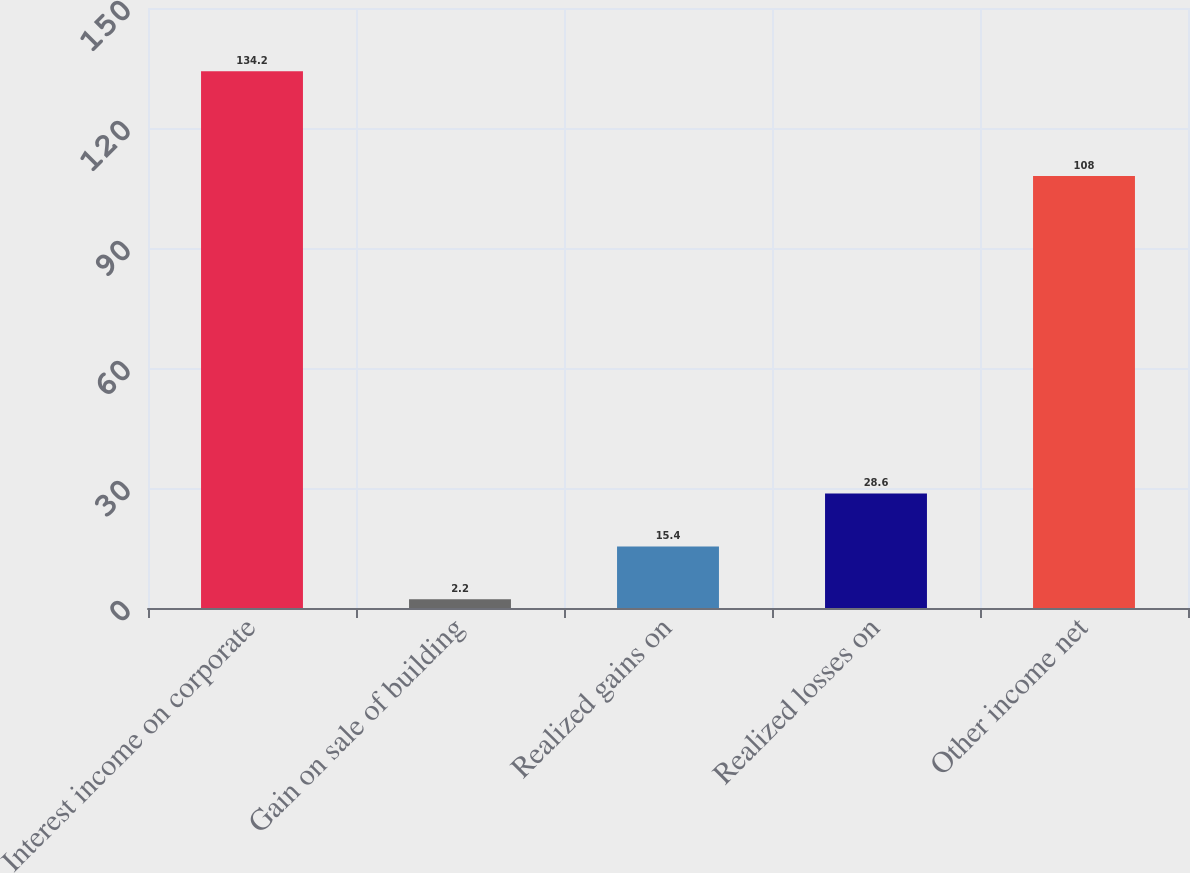Convert chart. <chart><loc_0><loc_0><loc_500><loc_500><bar_chart><fcel>Interest income on corporate<fcel>Gain on sale of building<fcel>Realized gains on<fcel>Realized losses on<fcel>Other income net<nl><fcel>134.2<fcel>2.2<fcel>15.4<fcel>28.6<fcel>108<nl></chart> 